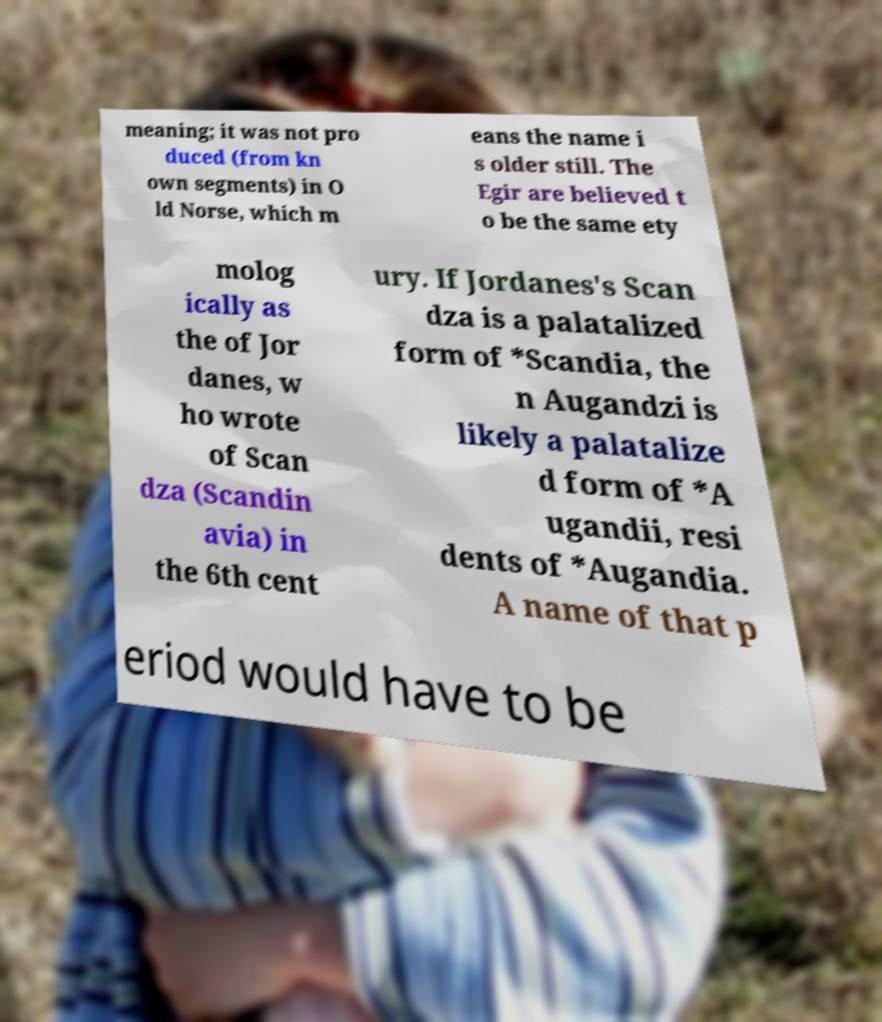Can you read and provide the text displayed in the image?This photo seems to have some interesting text. Can you extract and type it out for me? meaning; it was not pro duced (from kn own segments) in O ld Norse, which m eans the name i s older still. The Egir are believed t o be the same ety molog ically as the of Jor danes, w ho wrote of Scan dza (Scandin avia) in the 6th cent ury. If Jordanes's Scan dza is a palatalized form of *Scandia, the n Augandzi is likely a palatalize d form of *A ugandii, resi dents of *Augandia. A name of that p eriod would have to be 